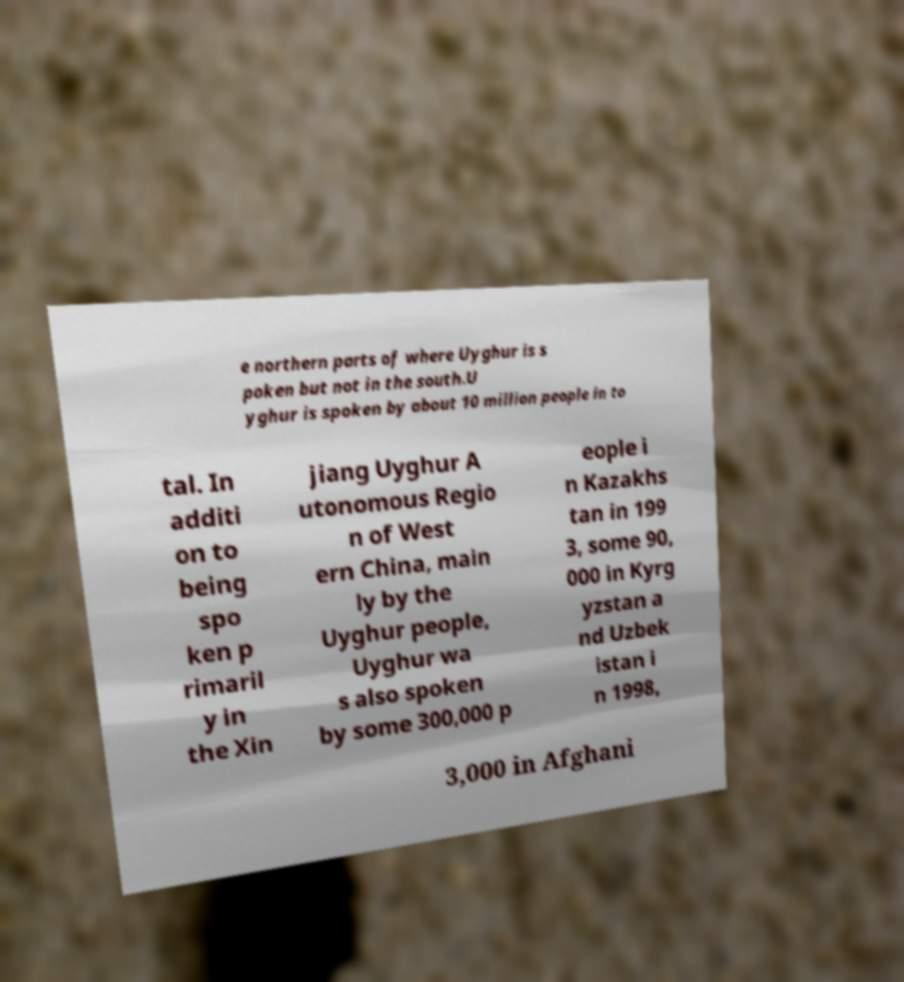What messages or text are displayed in this image? I need them in a readable, typed format. e northern parts of where Uyghur is s poken but not in the south.U yghur is spoken by about 10 million people in to tal. In additi on to being spo ken p rimaril y in the Xin jiang Uyghur A utonomous Regio n of West ern China, main ly by the Uyghur people, Uyghur wa s also spoken by some 300,000 p eople i n Kazakhs tan in 199 3, some 90, 000 in Kyrg yzstan a nd Uzbek istan i n 1998, 3,000 in Afghani 